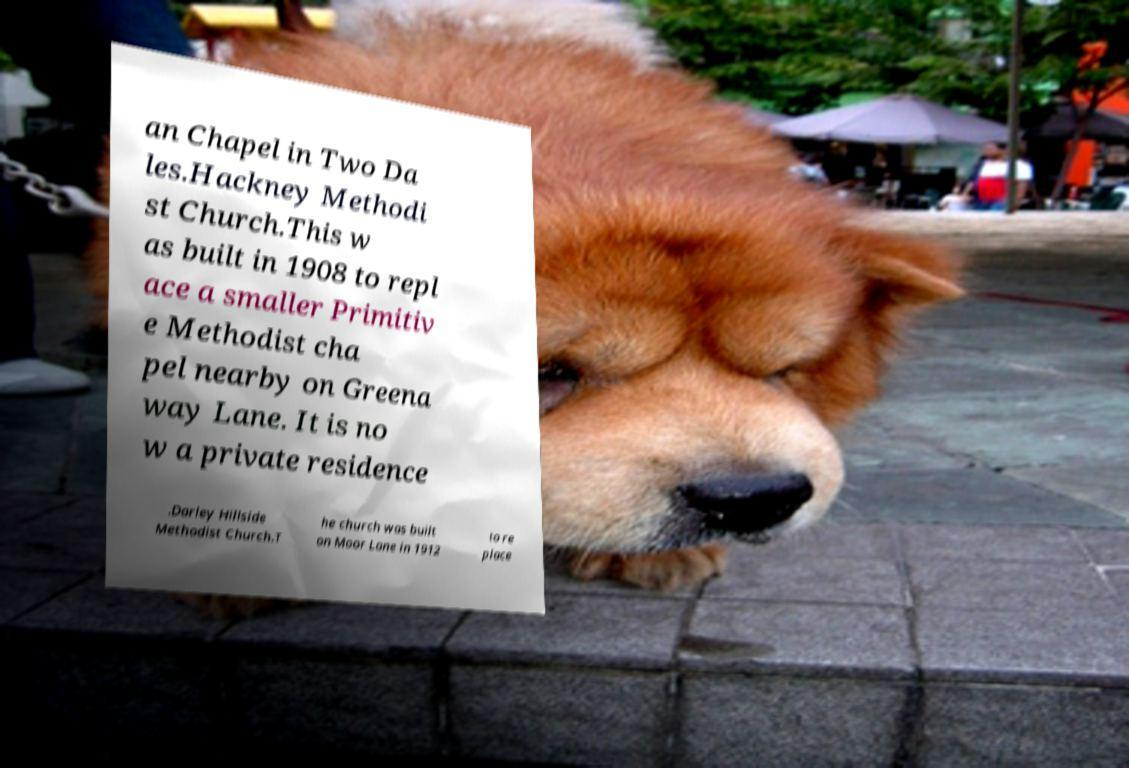Can you read and provide the text displayed in the image?This photo seems to have some interesting text. Can you extract and type it out for me? an Chapel in Two Da les.Hackney Methodi st Church.This w as built in 1908 to repl ace a smaller Primitiv e Methodist cha pel nearby on Greena way Lane. It is no w a private residence .Darley Hillside Methodist Church.T he church was built on Moor Lane in 1912 to re place 